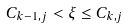Convert formula to latex. <formula><loc_0><loc_0><loc_500><loc_500>C _ { k - 1 , j } < \xi \leq C _ { k , j }</formula> 